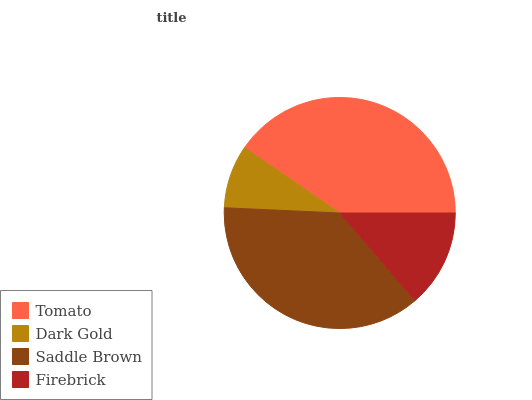Is Dark Gold the minimum?
Answer yes or no. Yes. Is Tomato the maximum?
Answer yes or no. Yes. Is Saddle Brown the minimum?
Answer yes or no. No. Is Saddle Brown the maximum?
Answer yes or no. No. Is Saddle Brown greater than Dark Gold?
Answer yes or no. Yes. Is Dark Gold less than Saddle Brown?
Answer yes or no. Yes. Is Dark Gold greater than Saddle Brown?
Answer yes or no. No. Is Saddle Brown less than Dark Gold?
Answer yes or no. No. Is Saddle Brown the high median?
Answer yes or no. Yes. Is Firebrick the low median?
Answer yes or no. Yes. Is Tomato the high median?
Answer yes or no. No. Is Tomato the low median?
Answer yes or no. No. 